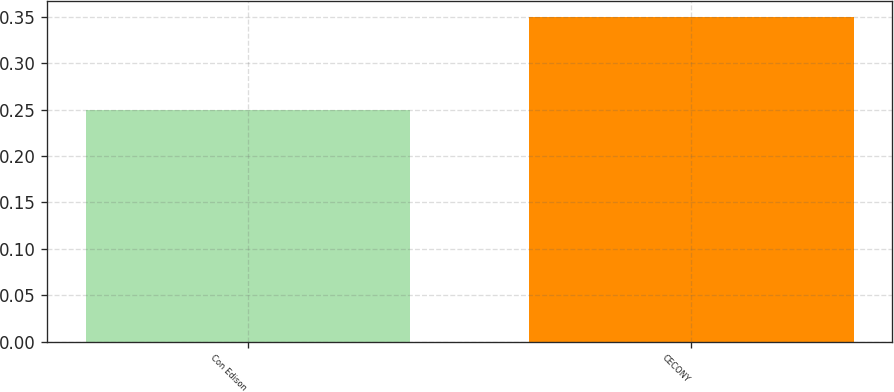Convert chart to OTSL. <chart><loc_0><loc_0><loc_500><loc_500><bar_chart><fcel>Con Edison<fcel>CECONY<nl><fcel>0.25<fcel>0.35<nl></chart> 